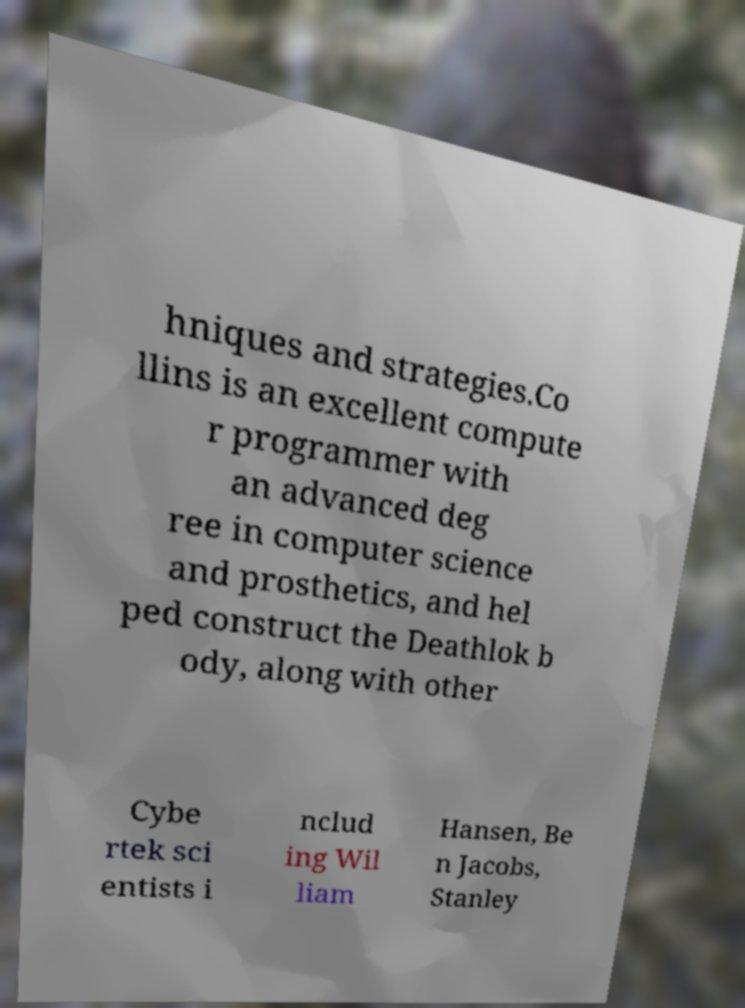There's text embedded in this image that I need extracted. Can you transcribe it verbatim? hniques and strategies.Co llins is an excellent compute r programmer with an advanced deg ree in computer science and prosthetics, and hel ped construct the Deathlok b ody, along with other Cybe rtek sci entists i nclud ing Wil liam Hansen, Be n Jacobs, Stanley 